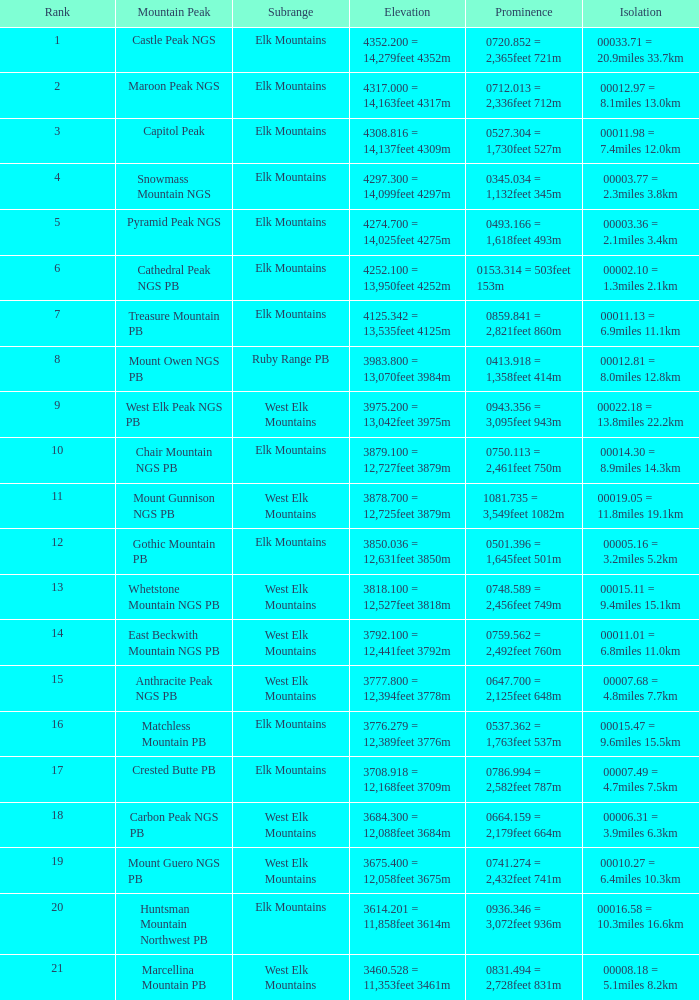Name the Prominence of the Mountain Peak of matchless mountain pb? 0537.362 = 1,763feet 537m. 